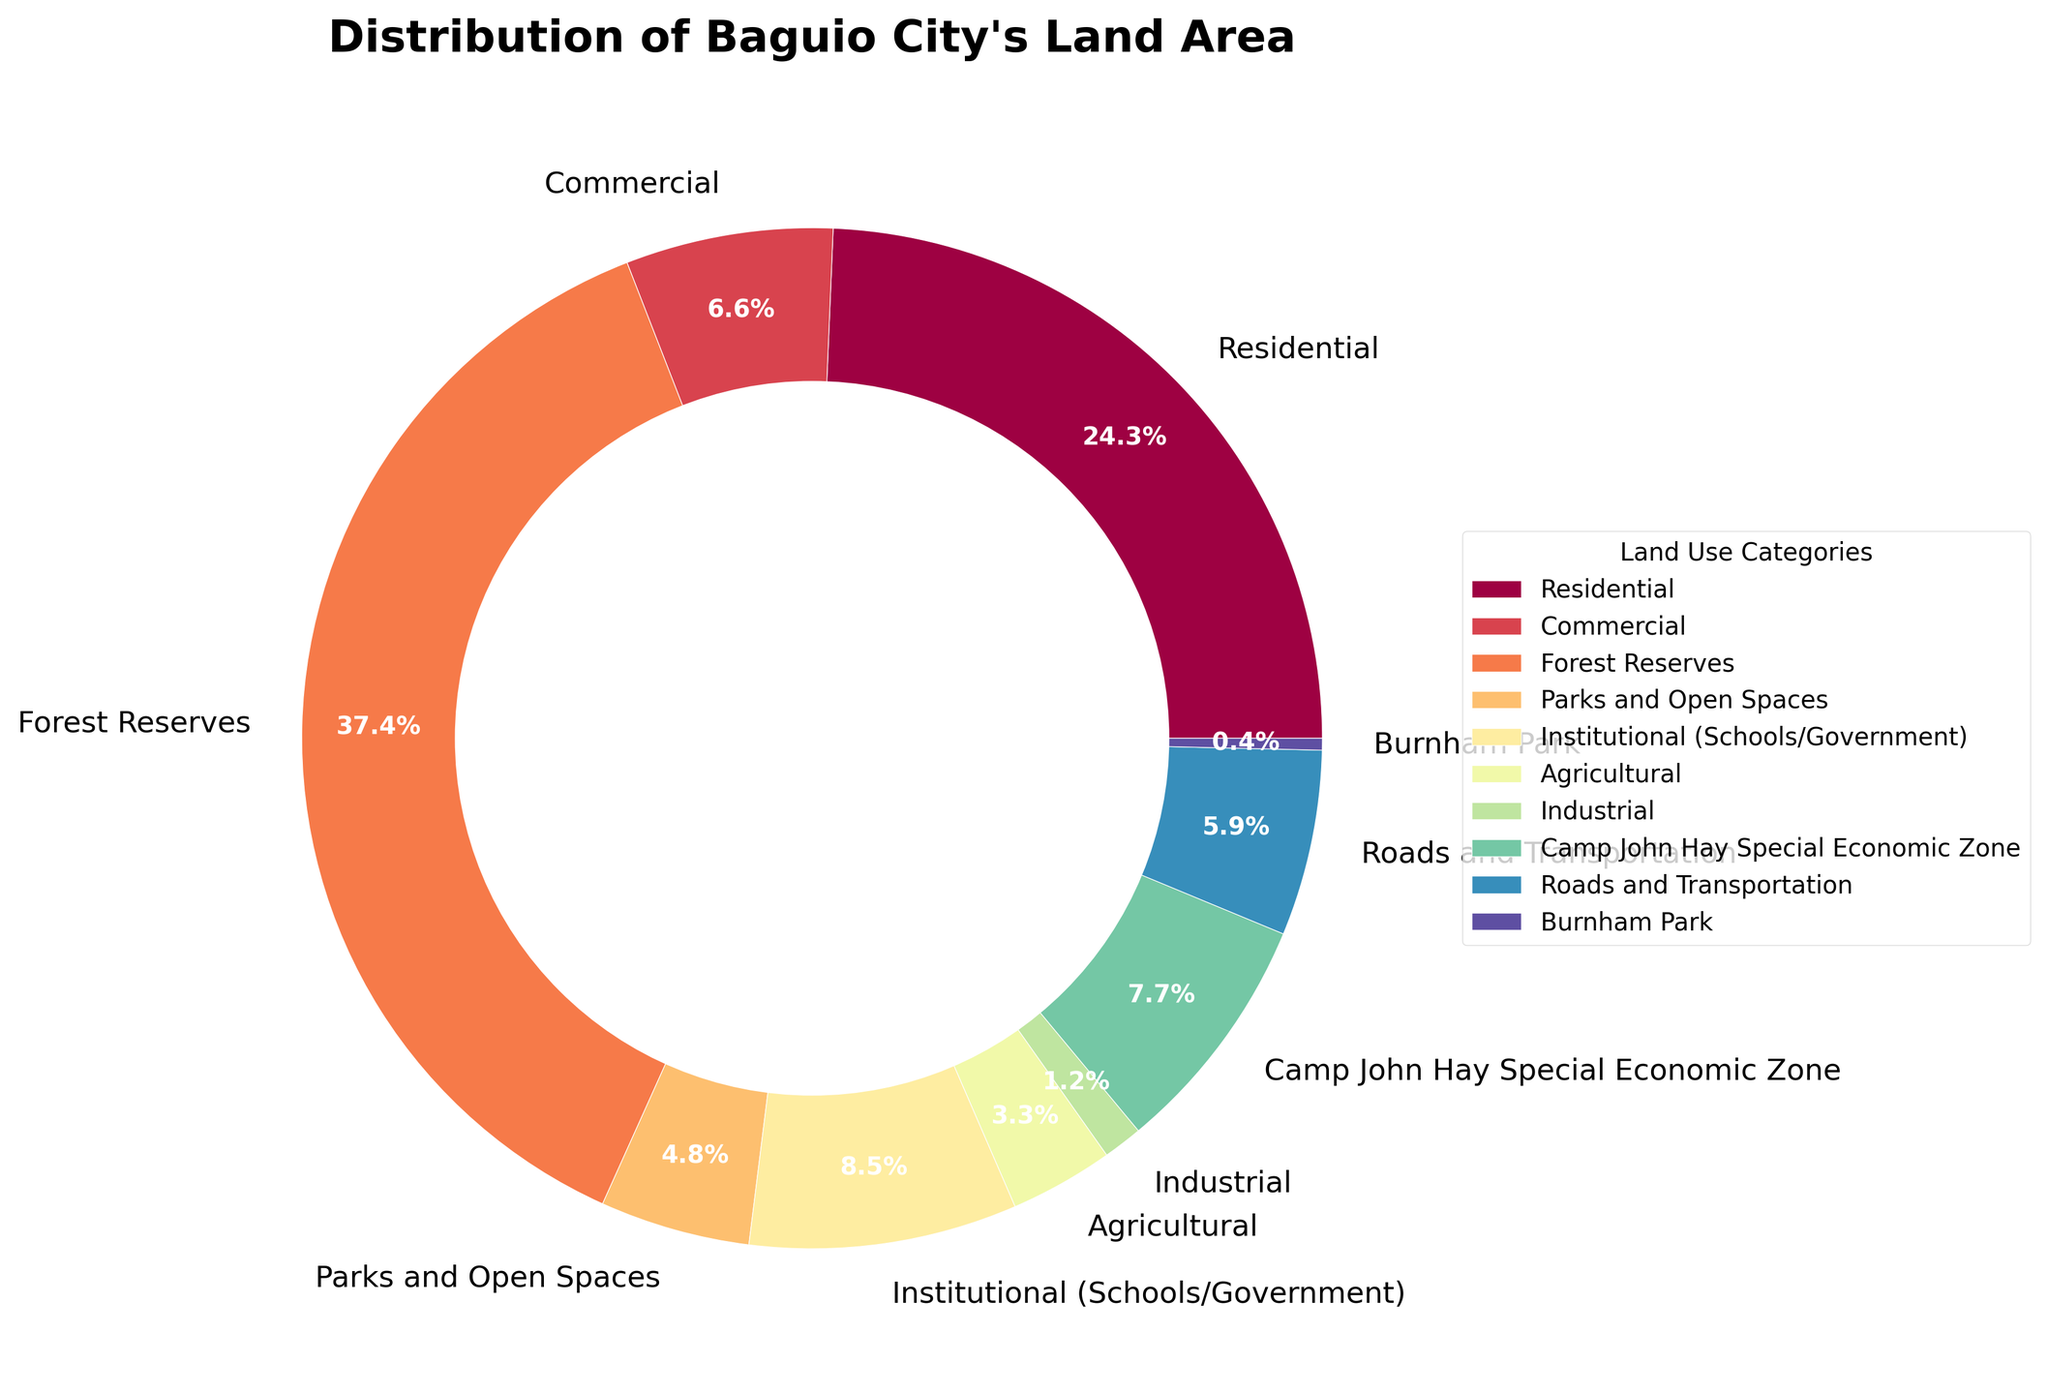What's the largest land use category in Baguio City's land area distribution? To find this, look for the wedge with the greatest percentage in the pie chart. The largest section should represent the land category with the highest usage.
Answer: Forest Reserves What percentage of Baguio City's land area is used for residential purposes? Identify the pie chart wedge labeled "Residential." The percentage value will be displayed in the wedge itself.
Answer: 22.9% How does the area allocated to institutional use compare to that of commercial use? Check the wedges labeled "Institutional (Schools/Government)" and "Commercial" and compare their percentage values. Institutional use has a larger percentage than commercial use.
Answer: Institutional use is greater than commercial use What is the combined percentage of the land used for Parks and Open Spaces, Roads and Transportation, and Burnham Park? Find the wedges for "Parks and Open Spaces," "Roads and Transportation," and "Burnham Park." Sum up their percentage values.
Answer: 4.5% (Parks and Open Spaces) + 5.1% (Roads and Transportation) + 0.3% (Burnham Park) = 9.9% Which is the smaller land use category, Industrial or Agricultural? Find the wedges labeled "Industrial" and "Agricultural" and compare their percentage values. Agricultural has a larger percentage than Industrial.
Answer: Industrial How does the area for Agricultural use compare to Burnham Park? Check the wedges labeled "Agricultural" and "Burnham Park." Compare their percentage values. Agricultural has a significantly higher percentage than Burnham Park.
Answer: Agricultural use is larger than Burnham Park What is the total area (in hectares) dedicated to Commercial and Residential uses combined? Find the wedge for the residential (22.9%) and commercial (6.2%) uses in hectares. 2150 (Residential) + 580 (Commercial) = 2730 hectares.
Answer: 2730 hectares How much more area is allocated to Forest Reserves compared to Parks and Open Spaces? Look at the percentage values for "Forest Reserves" (35.2%) and "Parks and Open Spaces" (4.5%) and convert them back to hectares (using totals in data). Forest Reserves have 3300 hectares, while Parks and Open Spaces have 420 hectares. 3300 - 420 = 2880 hectares difference.
Answer: 2880 hectares What visual feature helps identify the pie chart section for Burnham Park? In the chart, the wedge labeled "Burnham Park" is small and likely has distinct colors, making it easier to spot.
Answer: Small wedge with distinct color What's the least represented land use category in Baguio City's land area distribution? Find the smallest wedge by percentage in the pie chart. The smallest section has the lowest percentage.
Answer: Burnham Park 